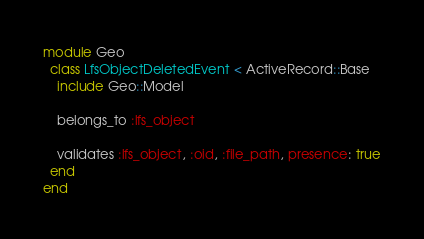Convert code to text. <code><loc_0><loc_0><loc_500><loc_500><_Ruby_>module Geo
  class LfsObjectDeletedEvent < ActiveRecord::Base
    include Geo::Model

    belongs_to :lfs_object

    validates :lfs_object, :oid, :file_path, presence: true
  end
end
</code> 